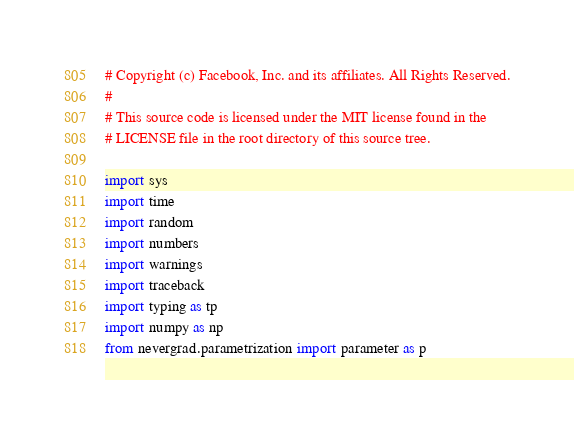Convert code to text. <code><loc_0><loc_0><loc_500><loc_500><_Python_># Copyright (c) Facebook, Inc. and its affiliates. All Rights Reserved.
#
# This source code is licensed under the MIT license found in the
# LICENSE file in the root directory of this source tree.

import sys
import time
import random
import numbers
import warnings
import traceback
import typing as tp
import numpy as np
from nevergrad.parametrization import parameter as p</code> 